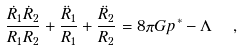Convert formula to latex. <formula><loc_0><loc_0><loc_500><loc_500>\frac { \dot { R } _ { 1 } \dot { R } _ { 2 } } { R _ { 1 } R _ { 2 } } + \frac { \ddot { R } _ { 1 } } { R _ { 1 } } + \frac { \ddot { R } _ { 2 } } { R _ { 2 } } = 8 \pi G p ^ { * } - \Lambda \ \ ,</formula> 